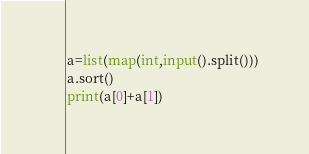<code> <loc_0><loc_0><loc_500><loc_500><_Python_>a=list(map(int,input().split()))
a.sort()
print(a[0]+a[1])</code> 